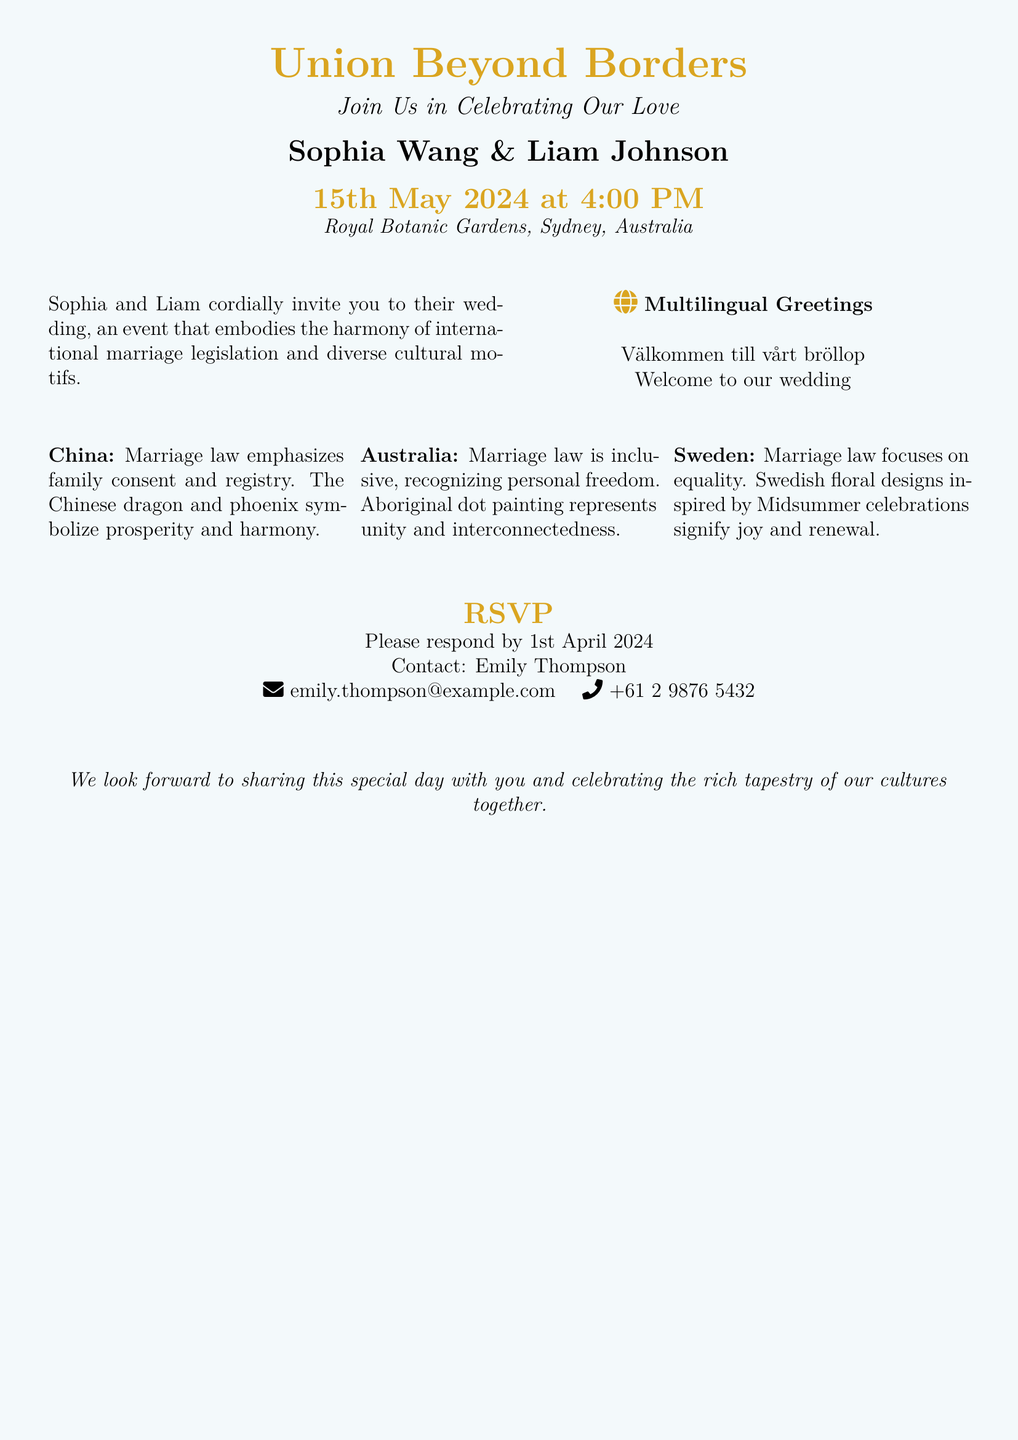What is the date of the wedding? The date of the wedding is explicitly mentioned in the document as 15th May 2024.
Answer: 15th May 2024 Who are the couple getting married? The names of the couple getting married are mentioned prominently in the document as Sophia Wang and Liam Johnson.
Answer: Sophia Wang & Liam Johnson Where is the wedding taking place? The location of the wedding is specified in the document as Royal Botanic Gardens, Sydney, Australia.
Answer: Royal Botanic Gardens, Sydney, Australia What is the RSVP deadline? The document states that the RSVP deadline is 1st April 2024.
Answer: 1st April 2024 What motif represents unity in the Australian context? The document refers to Aboriginal dot painting as the motif that represents unity in Australia.
Answer: Aboriginal dot painting What does the Chinese dragon and phoenix symbolize? The document mentions that the dragon and phoenix symbolize prosperity and harmony in the Chinese context.
Answer: Prosperity and harmony What elements do the wedding invitation illustrate? The invitation illustrates the harmony of international marriage legislation and diverse cultural motifs.
Answer: International marriage legislation and diverse cultural motifs Which languages are used in the multilingual greetings? The multilingual greetings include Chinese, Swedish, and English as indicated in the document.
Answer: Chinese, Swedish, and English Who is the contact person for the RSVP? The document specifies Emily Thompson as the contact person for the RSVP.
Answer: Emily Thompson 